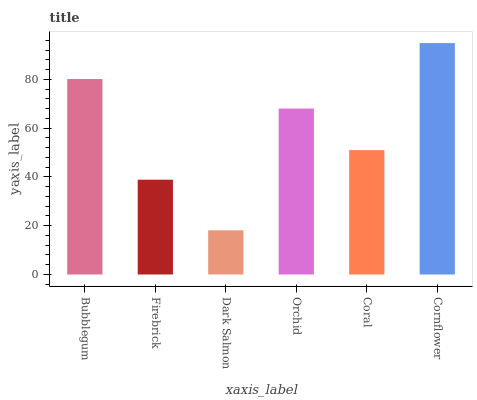Is Cornflower the maximum?
Answer yes or no. Yes. Is Firebrick the minimum?
Answer yes or no. No. Is Firebrick the maximum?
Answer yes or no. No. Is Bubblegum greater than Firebrick?
Answer yes or no. Yes. Is Firebrick less than Bubblegum?
Answer yes or no. Yes. Is Firebrick greater than Bubblegum?
Answer yes or no. No. Is Bubblegum less than Firebrick?
Answer yes or no. No. Is Orchid the high median?
Answer yes or no. Yes. Is Coral the low median?
Answer yes or no. Yes. Is Coral the high median?
Answer yes or no. No. Is Orchid the low median?
Answer yes or no. No. 